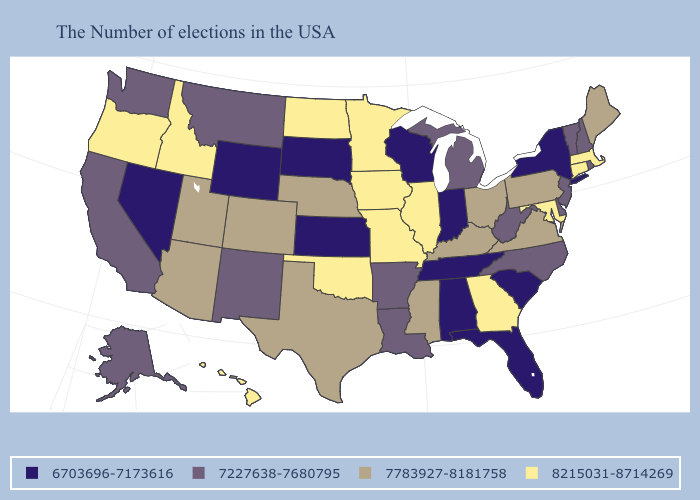Name the states that have a value in the range 6703696-7173616?
Answer briefly. New York, South Carolina, Florida, Indiana, Alabama, Tennessee, Wisconsin, Kansas, South Dakota, Wyoming, Nevada. Does South Carolina have the lowest value in the South?
Be succinct. Yes. What is the value of Idaho?
Answer briefly. 8215031-8714269. What is the value of New York?
Short answer required. 6703696-7173616. How many symbols are there in the legend?
Be succinct. 4. Name the states that have a value in the range 8215031-8714269?
Answer briefly. Massachusetts, Connecticut, Maryland, Georgia, Illinois, Missouri, Minnesota, Iowa, Oklahoma, North Dakota, Idaho, Oregon, Hawaii. Which states have the lowest value in the USA?
Keep it brief. New York, South Carolina, Florida, Indiana, Alabama, Tennessee, Wisconsin, Kansas, South Dakota, Wyoming, Nevada. Which states hav the highest value in the MidWest?
Keep it brief. Illinois, Missouri, Minnesota, Iowa, North Dakota. What is the value of Wyoming?
Give a very brief answer. 6703696-7173616. What is the lowest value in the West?
Concise answer only. 6703696-7173616. Does Alabama have the lowest value in the South?
Answer briefly. Yes. Among the states that border Missouri , which have the highest value?
Concise answer only. Illinois, Iowa, Oklahoma. What is the highest value in states that border Delaware?
Write a very short answer. 8215031-8714269. Does North Dakota have the lowest value in the MidWest?
Concise answer only. No. What is the value of Vermont?
Be succinct. 7227638-7680795. 